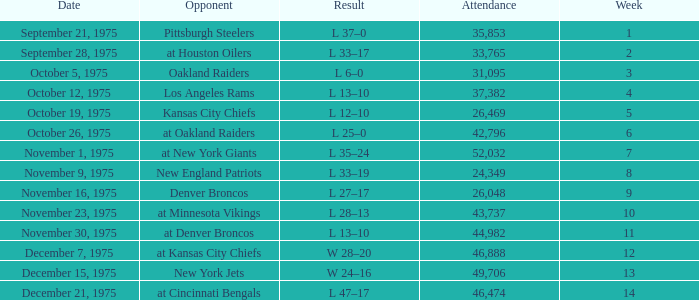What is the highest Week when the opponent was kansas city chiefs, with more than 26,469 in attendance? None. Give me the full table as a dictionary. {'header': ['Date', 'Opponent', 'Result', 'Attendance', 'Week'], 'rows': [['September 21, 1975', 'Pittsburgh Steelers', 'L 37–0', '35,853', '1'], ['September 28, 1975', 'at Houston Oilers', 'L 33–17', '33,765', '2'], ['October 5, 1975', 'Oakland Raiders', 'L 6–0', '31,095', '3'], ['October 12, 1975', 'Los Angeles Rams', 'L 13–10', '37,382', '4'], ['October 19, 1975', 'Kansas City Chiefs', 'L 12–10', '26,469', '5'], ['October 26, 1975', 'at Oakland Raiders', 'L 25–0', '42,796', '6'], ['November 1, 1975', 'at New York Giants', 'L 35–24', '52,032', '7'], ['November 9, 1975', 'New England Patriots', 'L 33–19', '24,349', '8'], ['November 16, 1975', 'Denver Broncos', 'L 27–17', '26,048', '9'], ['November 23, 1975', 'at Minnesota Vikings', 'L 28–13', '43,737', '10'], ['November 30, 1975', 'at Denver Broncos', 'L 13–10', '44,982', '11'], ['December 7, 1975', 'at Kansas City Chiefs', 'W 28–20', '46,888', '12'], ['December 15, 1975', 'New York Jets', 'W 24–16', '49,706', '13'], ['December 21, 1975', 'at Cincinnati Bengals', 'L 47–17', '46,474', '14']]} 